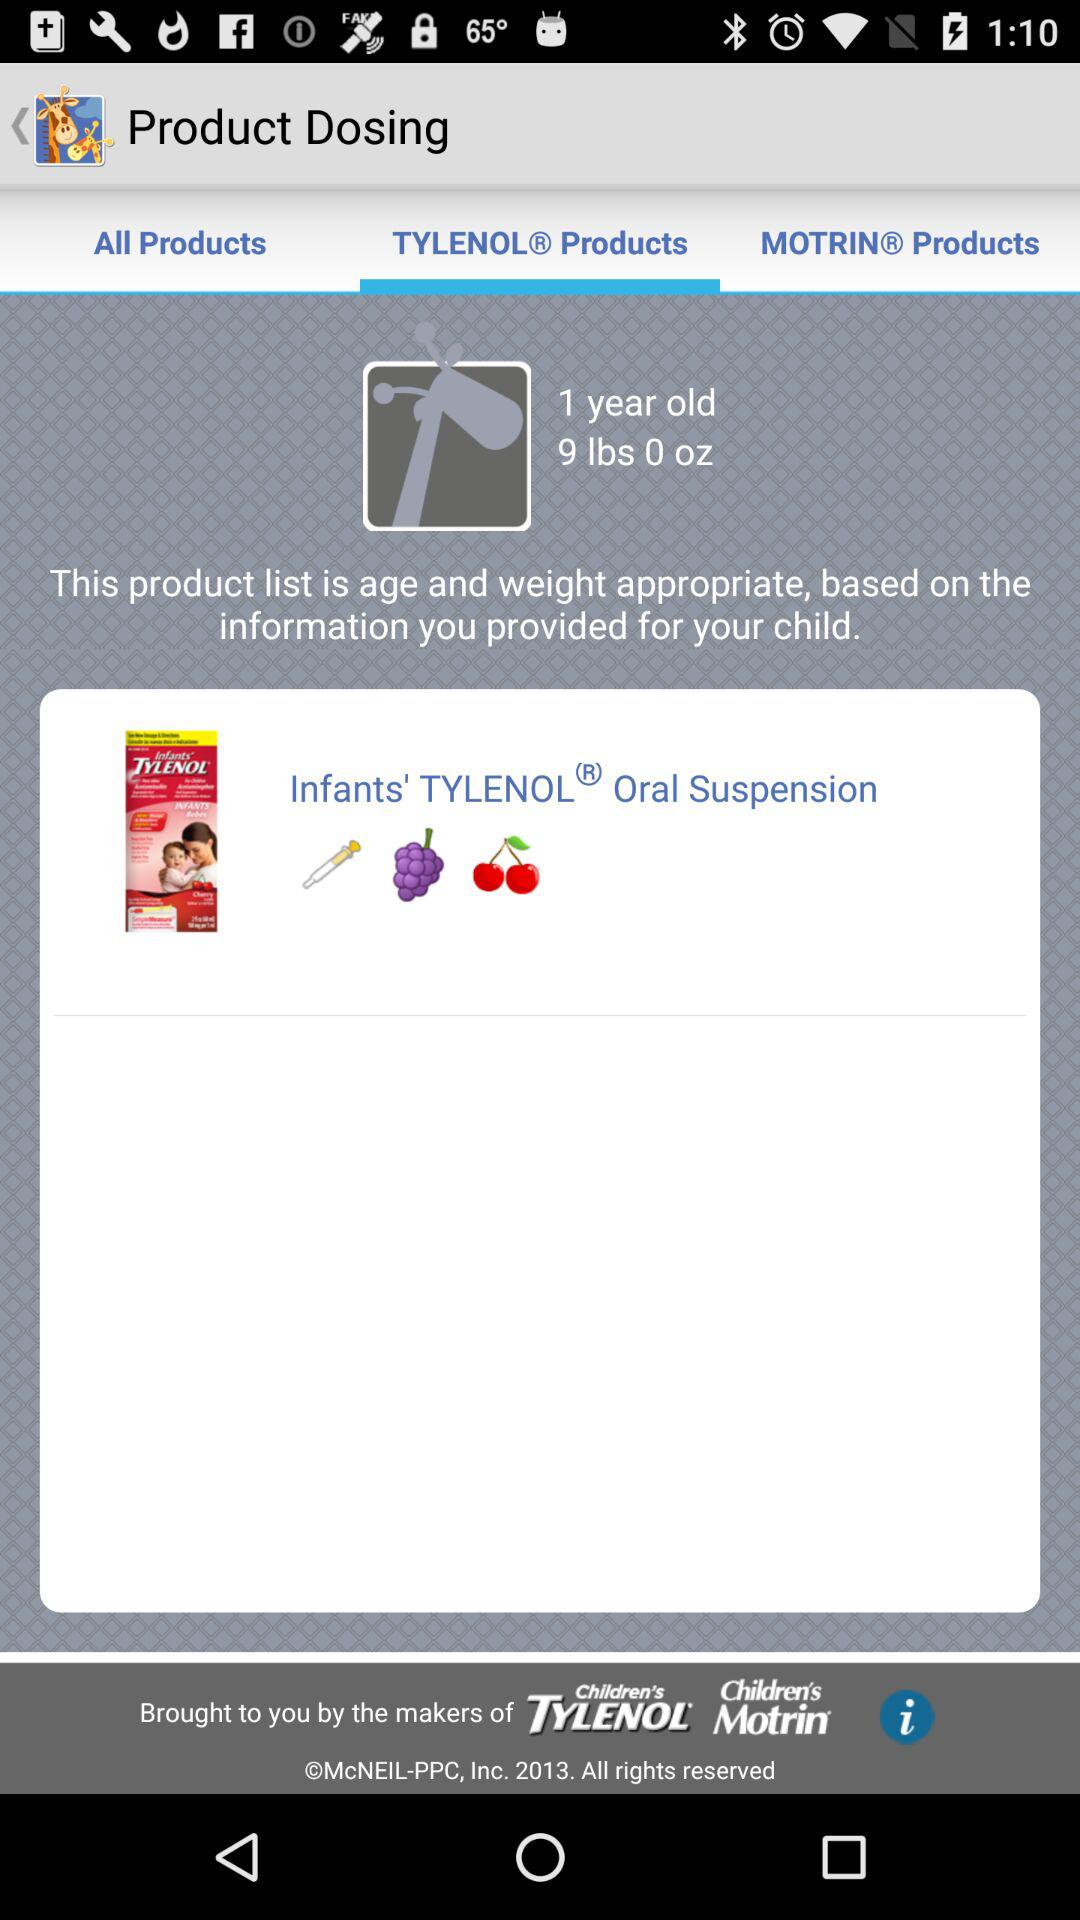What is the age of the child? The child is 1 year old. 